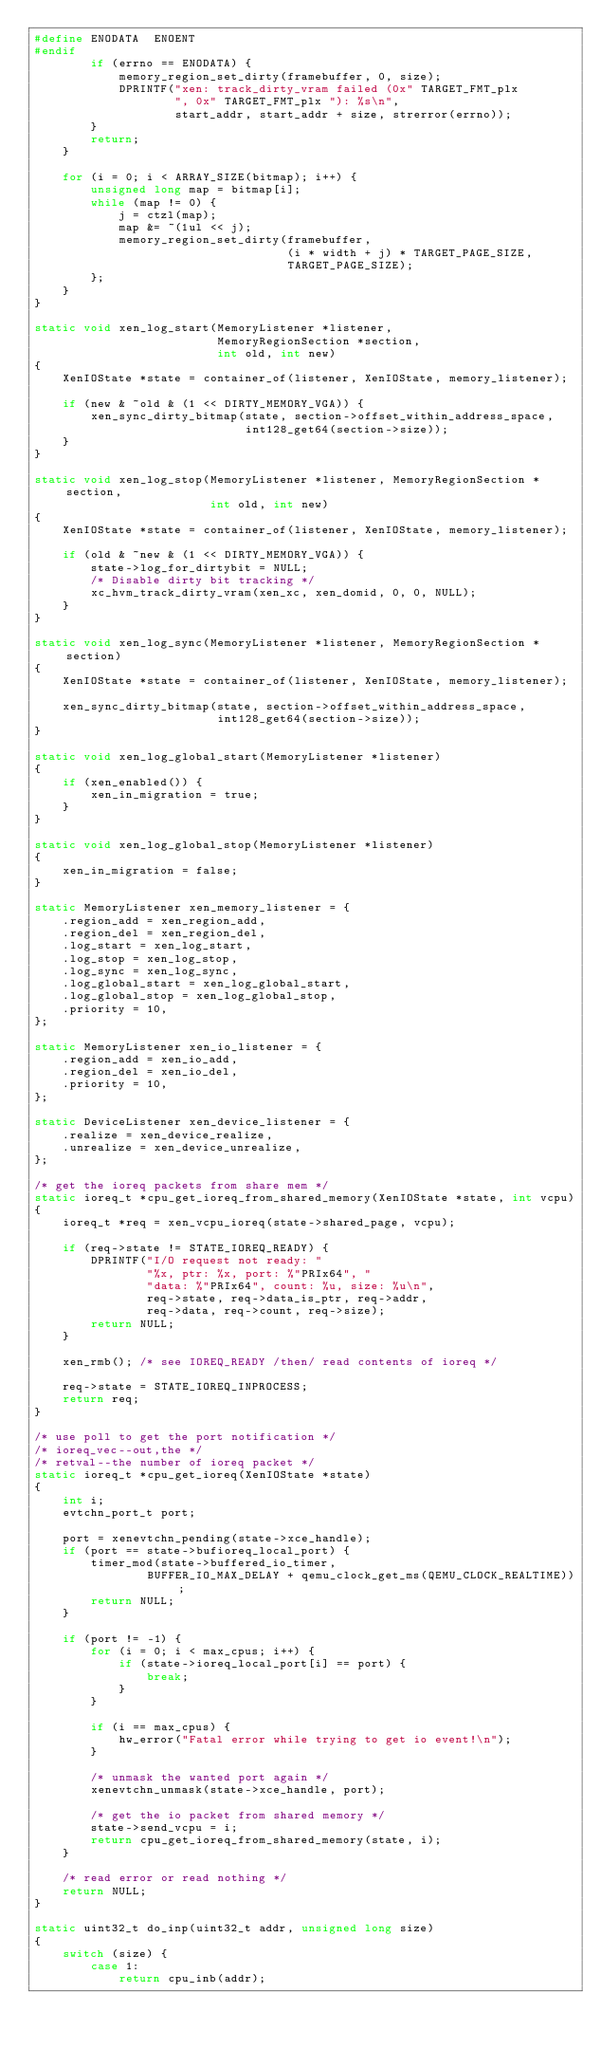<code> <loc_0><loc_0><loc_500><loc_500><_C_>#define ENODATA  ENOENT
#endif
        if (errno == ENODATA) {
            memory_region_set_dirty(framebuffer, 0, size);
            DPRINTF("xen: track_dirty_vram failed (0x" TARGET_FMT_plx
                    ", 0x" TARGET_FMT_plx "): %s\n",
                    start_addr, start_addr + size, strerror(errno));
        }
        return;
    }

    for (i = 0; i < ARRAY_SIZE(bitmap); i++) {
        unsigned long map = bitmap[i];
        while (map != 0) {
            j = ctzl(map);
            map &= ~(1ul << j);
            memory_region_set_dirty(framebuffer,
                                    (i * width + j) * TARGET_PAGE_SIZE,
                                    TARGET_PAGE_SIZE);
        };
    }
}

static void xen_log_start(MemoryListener *listener,
                          MemoryRegionSection *section,
                          int old, int new)
{
    XenIOState *state = container_of(listener, XenIOState, memory_listener);

    if (new & ~old & (1 << DIRTY_MEMORY_VGA)) {
        xen_sync_dirty_bitmap(state, section->offset_within_address_space,
                              int128_get64(section->size));
    }
}

static void xen_log_stop(MemoryListener *listener, MemoryRegionSection *section,
                         int old, int new)
{
    XenIOState *state = container_of(listener, XenIOState, memory_listener);

    if (old & ~new & (1 << DIRTY_MEMORY_VGA)) {
        state->log_for_dirtybit = NULL;
        /* Disable dirty bit tracking */
        xc_hvm_track_dirty_vram(xen_xc, xen_domid, 0, 0, NULL);
    }
}

static void xen_log_sync(MemoryListener *listener, MemoryRegionSection *section)
{
    XenIOState *state = container_of(listener, XenIOState, memory_listener);

    xen_sync_dirty_bitmap(state, section->offset_within_address_space,
                          int128_get64(section->size));
}

static void xen_log_global_start(MemoryListener *listener)
{
    if (xen_enabled()) {
        xen_in_migration = true;
    }
}

static void xen_log_global_stop(MemoryListener *listener)
{
    xen_in_migration = false;
}

static MemoryListener xen_memory_listener = {
    .region_add = xen_region_add,
    .region_del = xen_region_del,
    .log_start = xen_log_start,
    .log_stop = xen_log_stop,
    .log_sync = xen_log_sync,
    .log_global_start = xen_log_global_start,
    .log_global_stop = xen_log_global_stop,
    .priority = 10,
};

static MemoryListener xen_io_listener = {
    .region_add = xen_io_add,
    .region_del = xen_io_del,
    .priority = 10,
};

static DeviceListener xen_device_listener = {
    .realize = xen_device_realize,
    .unrealize = xen_device_unrealize,
};

/* get the ioreq packets from share mem */
static ioreq_t *cpu_get_ioreq_from_shared_memory(XenIOState *state, int vcpu)
{
    ioreq_t *req = xen_vcpu_ioreq(state->shared_page, vcpu);

    if (req->state != STATE_IOREQ_READY) {
        DPRINTF("I/O request not ready: "
                "%x, ptr: %x, port: %"PRIx64", "
                "data: %"PRIx64", count: %u, size: %u\n",
                req->state, req->data_is_ptr, req->addr,
                req->data, req->count, req->size);
        return NULL;
    }

    xen_rmb(); /* see IOREQ_READY /then/ read contents of ioreq */

    req->state = STATE_IOREQ_INPROCESS;
    return req;
}

/* use poll to get the port notification */
/* ioreq_vec--out,the */
/* retval--the number of ioreq packet */
static ioreq_t *cpu_get_ioreq(XenIOState *state)
{
    int i;
    evtchn_port_t port;

    port = xenevtchn_pending(state->xce_handle);
    if (port == state->bufioreq_local_port) {
        timer_mod(state->buffered_io_timer,
                BUFFER_IO_MAX_DELAY + qemu_clock_get_ms(QEMU_CLOCK_REALTIME));
        return NULL;
    }

    if (port != -1) {
        for (i = 0; i < max_cpus; i++) {
            if (state->ioreq_local_port[i] == port) {
                break;
            }
        }

        if (i == max_cpus) {
            hw_error("Fatal error while trying to get io event!\n");
        }

        /* unmask the wanted port again */
        xenevtchn_unmask(state->xce_handle, port);

        /* get the io packet from shared memory */
        state->send_vcpu = i;
        return cpu_get_ioreq_from_shared_memory(state, i);
    }

    /* read error or read nothing */
    return NULL;
}

static uint32_t do_inp(uint32_t addr, unsigned long size)
{
    switch (size) {
        case 1:
            return cpu_inb(addr);</code> 